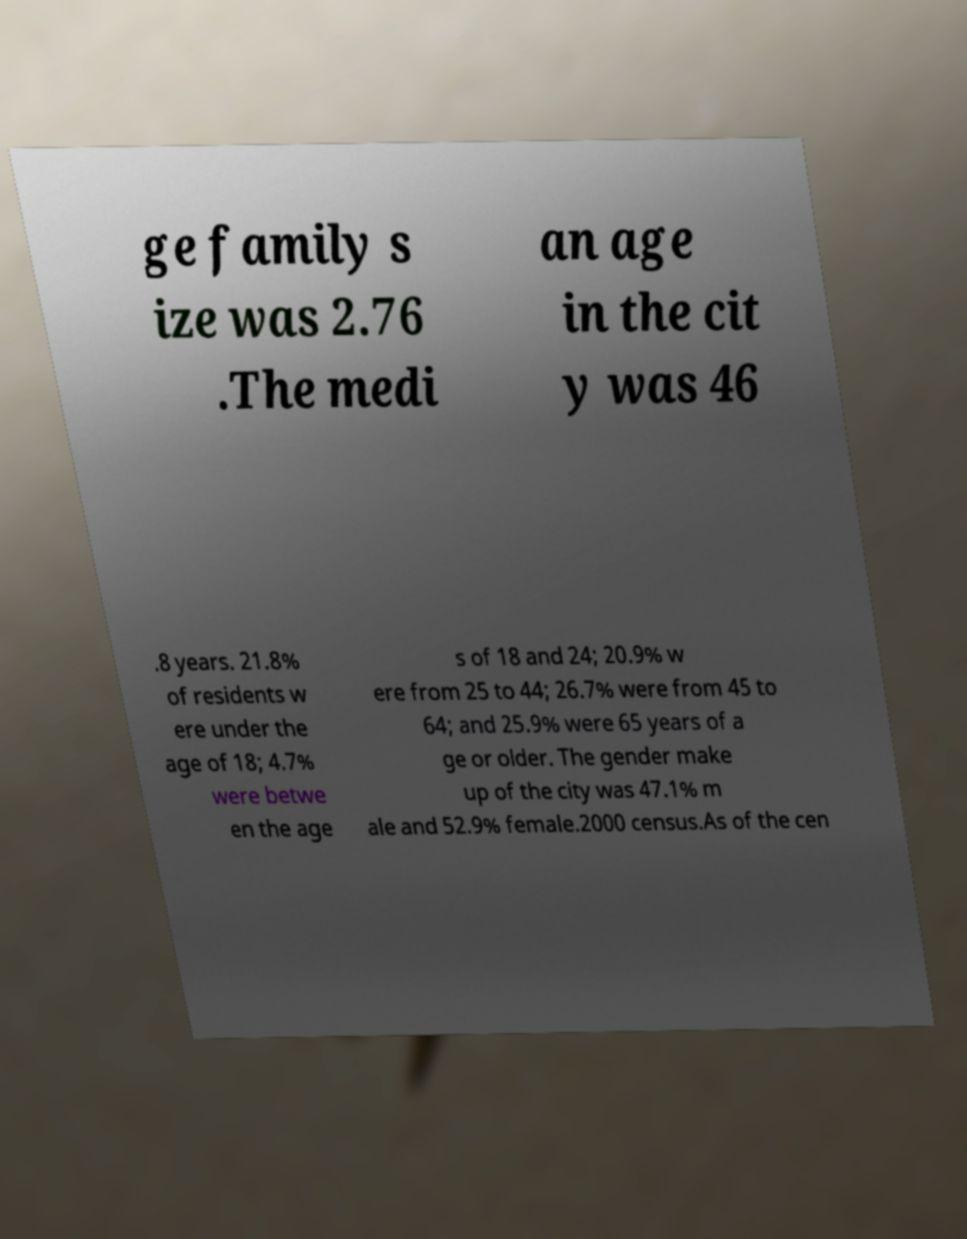Can you accurately transcribe the text from the provided image for me? ge family s ize was 2.76 .The medi an age in the cit y was 46 .8 years. 21.8% of residents w ere under the age of 18; 4.7% were betwe en the age s of 18 and 24; 20.9% w ere from 25 to 44; 26.7% were from 45 to 64; and 25.9% were 65 years of a ge or older. The gender make up of the city was 47.1% m ale and 52.9% female.2000 census.As of the cen 